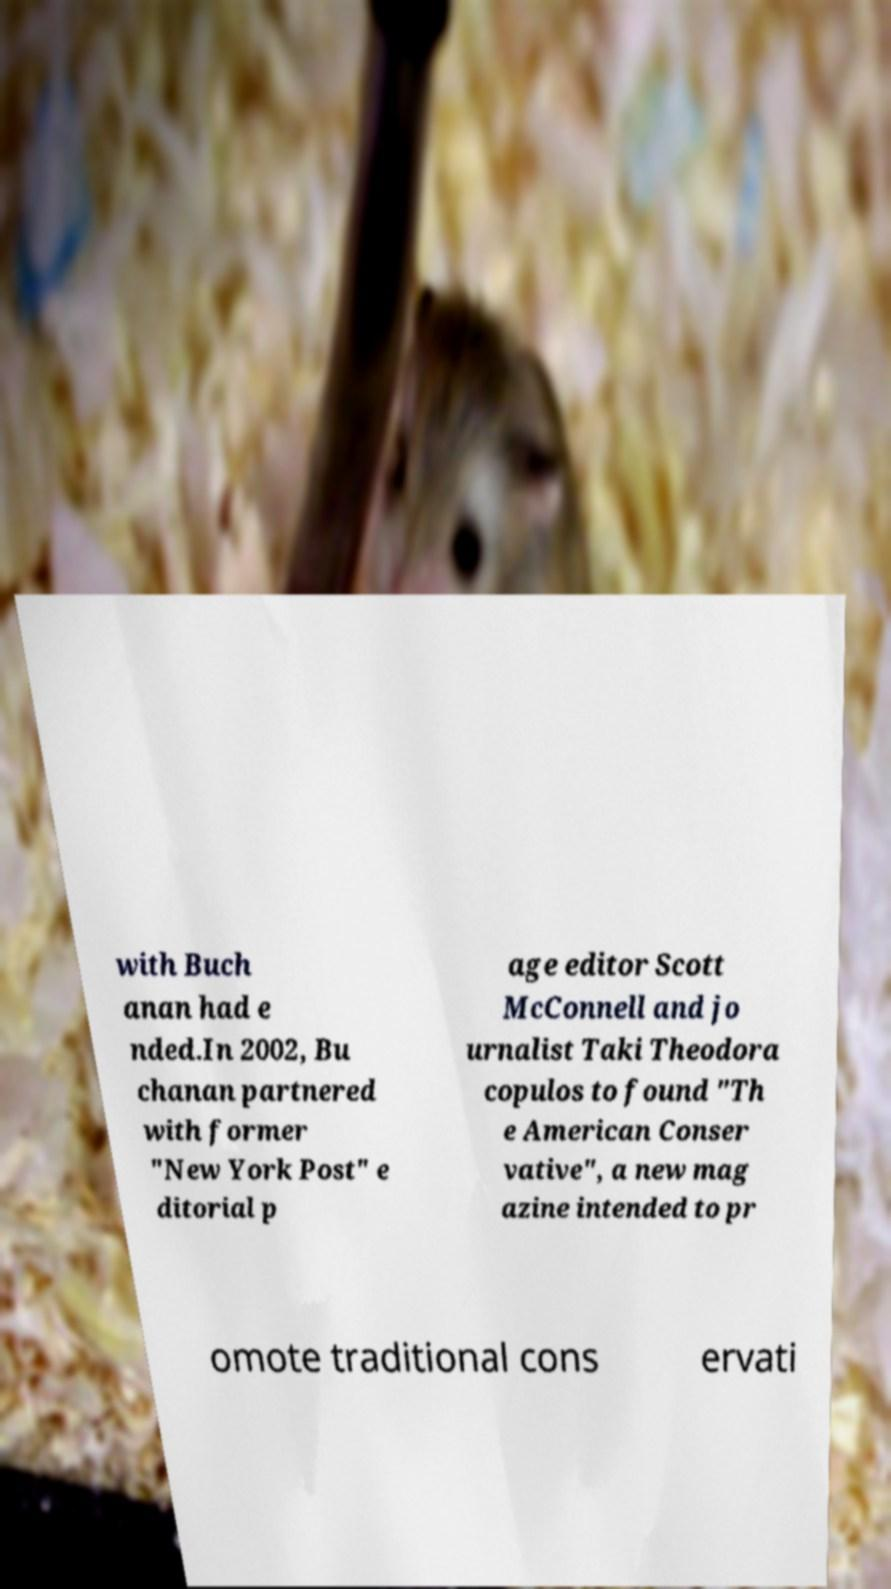What messages or text are displayed in this image? I need them in a readable, typed format. with Buch anan had e nded.In 2002, Bu chanan partnered with former "New York Post" e ditorial p age editor Scott McConnell and jo urnalist Taki Theodora copulos to found "Th e American Conser vative", a new mag azine intended to pr omote traditional cons ervati 